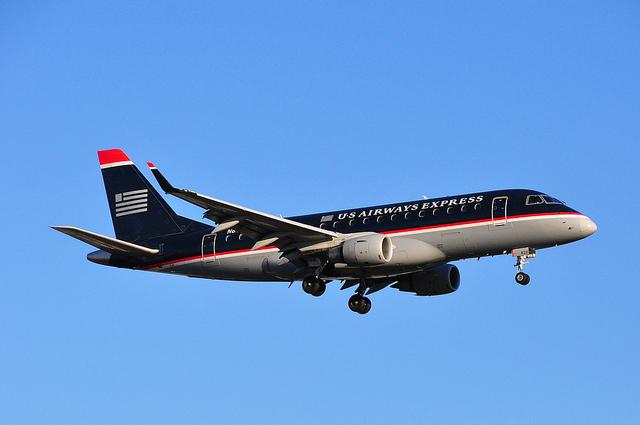What color is the tip of the tail?
Answer briefly. Red. Is the sky cloudy?
Short answer required. No. How old is this plane?
Quick response, please. Can't tell. How many clouds in the sky?
Write a very short answer. 0. What airline is the plane from?
Give a very brief answer. Us airways express. 